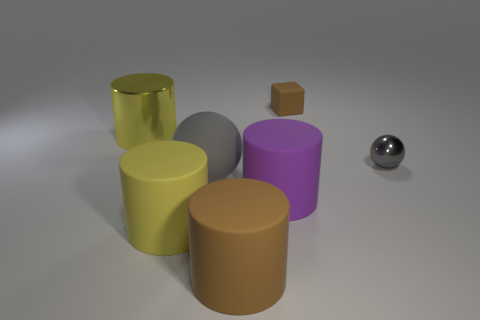Is the size of the gray matte ball the same as the gray metallic ball?
Your answer should be very brief. No. Is there a small purple metallic thing?
Make the answer very short. No. What is the size of the thing that is the same color as the tiny matte block?
Ensure brevity in your answer.  Large. There is a metal object on the left side of the gray thing that is left of the metallic object to the right of the small brown cube; how big is it?
Your answer should be very brief. Large. What number of brown cubes have the same material as the large purple cylinder?
Make the answer very short. 1. How many rubber blocks have the same size as the metal ball?
Your answer should be very brief. 1. What is the material of the brown object that is behind the yellow cylinder that is in front of the yellow cylinder that is behind the tiny gray ball?
Give a very brief answer. Rubber. How many things are brown cylinders or yellow matte cylinders?
Your answer should be compact. 2. What is the shape of the yellow shiny object?
Make the answer very short. Cylinder. What shape is the big yellow thing that is in front of the yellow thing that is behind the big purple thing?
Make the answer very short. Cylinder. 